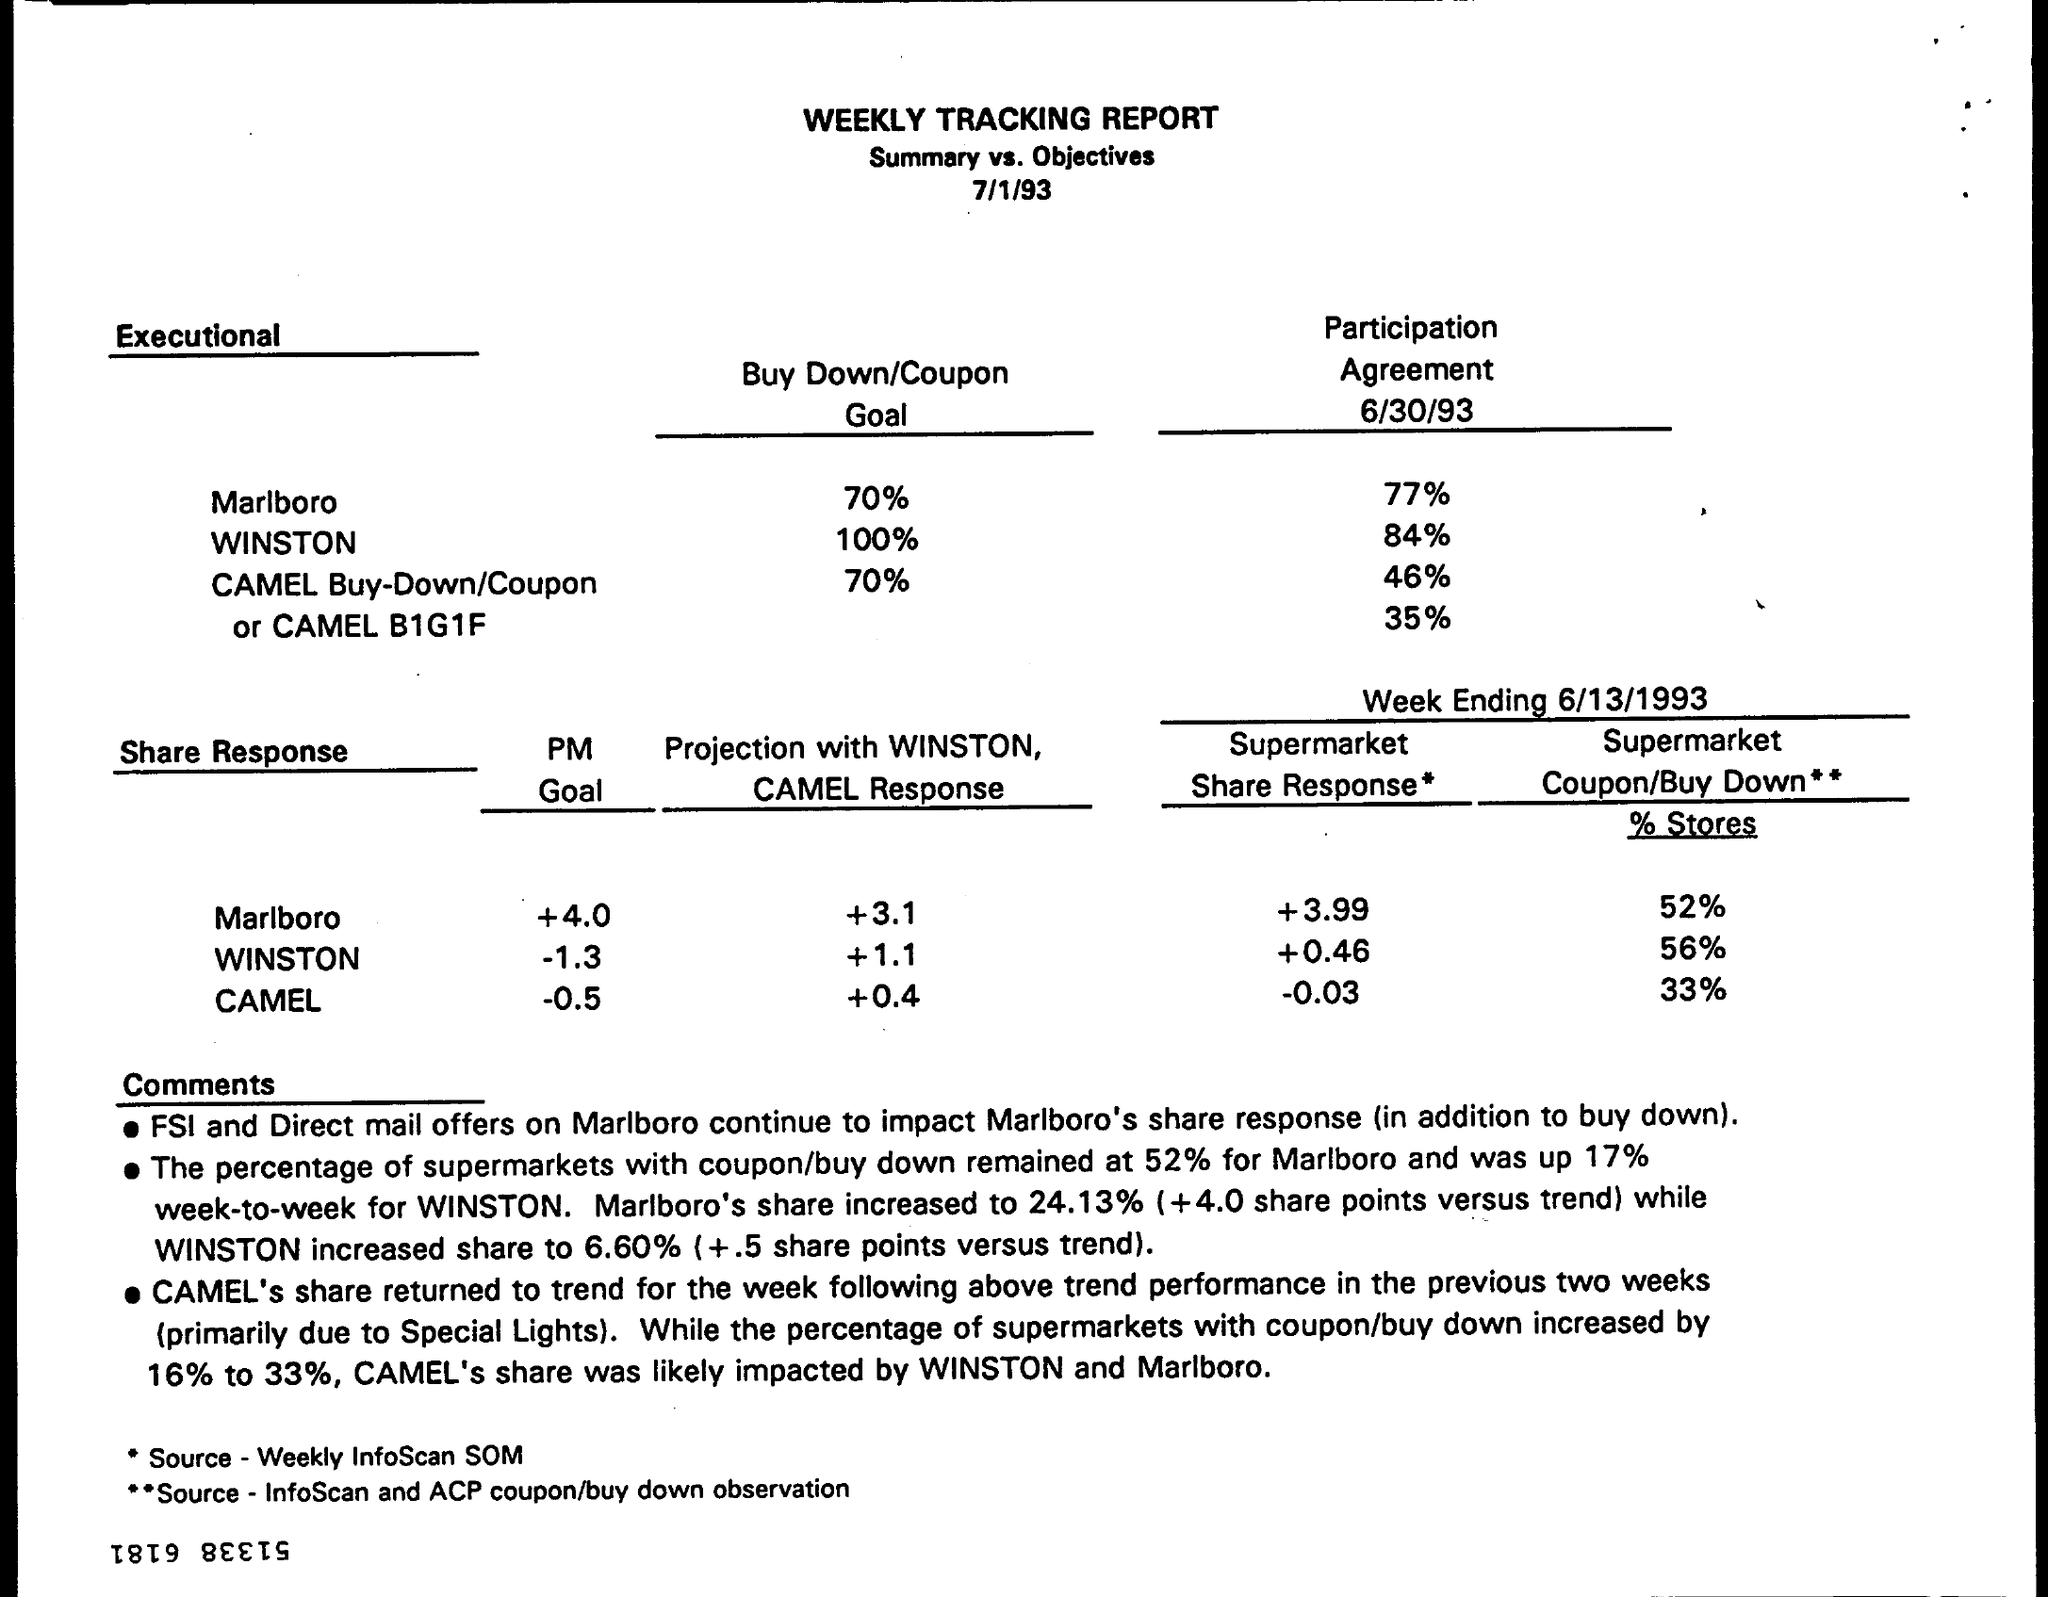Can you explain the significance of the Share Response figures in the report? The Share Response figures represent the change in market share for each brand relative to their projected trend or goal. For example, Marlboro achieved a +4.0, which means it surpassed its share response goal, indicating strong performance. WINSTON, on the other hand, saw a decrease of 1.3 points, suggesting a decline in its market share relative to its goal. CAMEL slightly underperformed with a -0.5 change in market share. These numbers are critical for understanding the competitive landscape and the impact of marketing strategies on brand performance. 